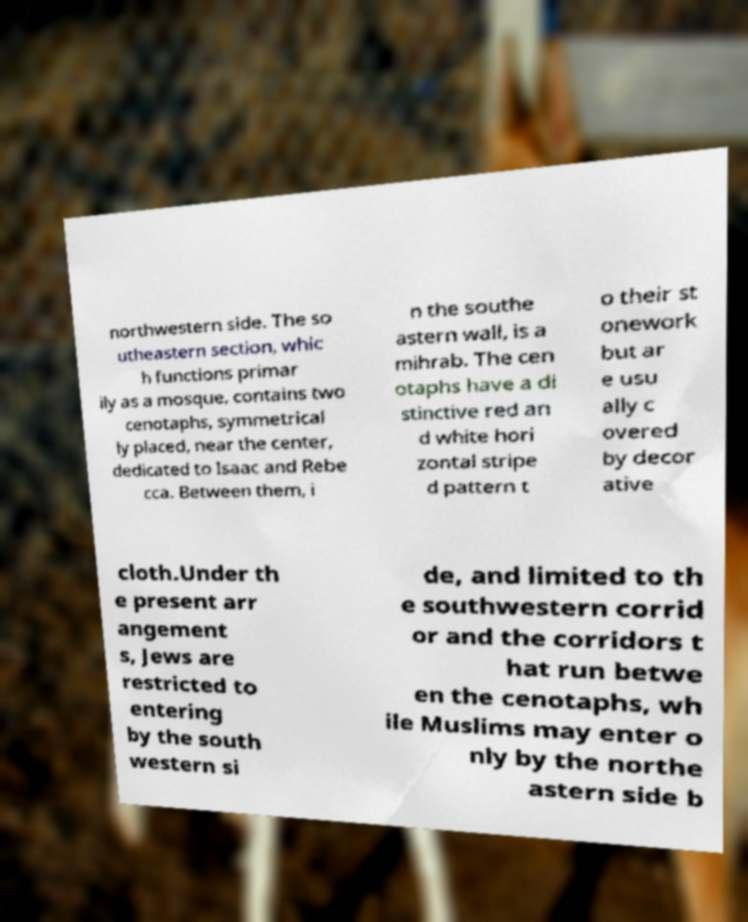Can you read and provide the text displayed in the image?This photo seems to have some interesting text. Can you extract and type it out for me? northwestern side. The so utheastern section, whic h functions primar ily as a mosque, contains two cenotaphs, symmetrical ly placed, near the center, dedicated to Isaac and Rebe cca. Between them, i n the southe astern wall, is a mihrab. The cen otaphs have a di stinctive red an d white hori zontal stripe d pattern t o their st onework but ar e usu ally c overed by decor ative cloth.Under th e present arr angement s, Jews are restricted to entering by the south western si de, and limited to th e southwestern corrid or and the corridors t hat run betwe en the cenotaphs, wh ile Muslims may enter o nly by the northe astern side b 